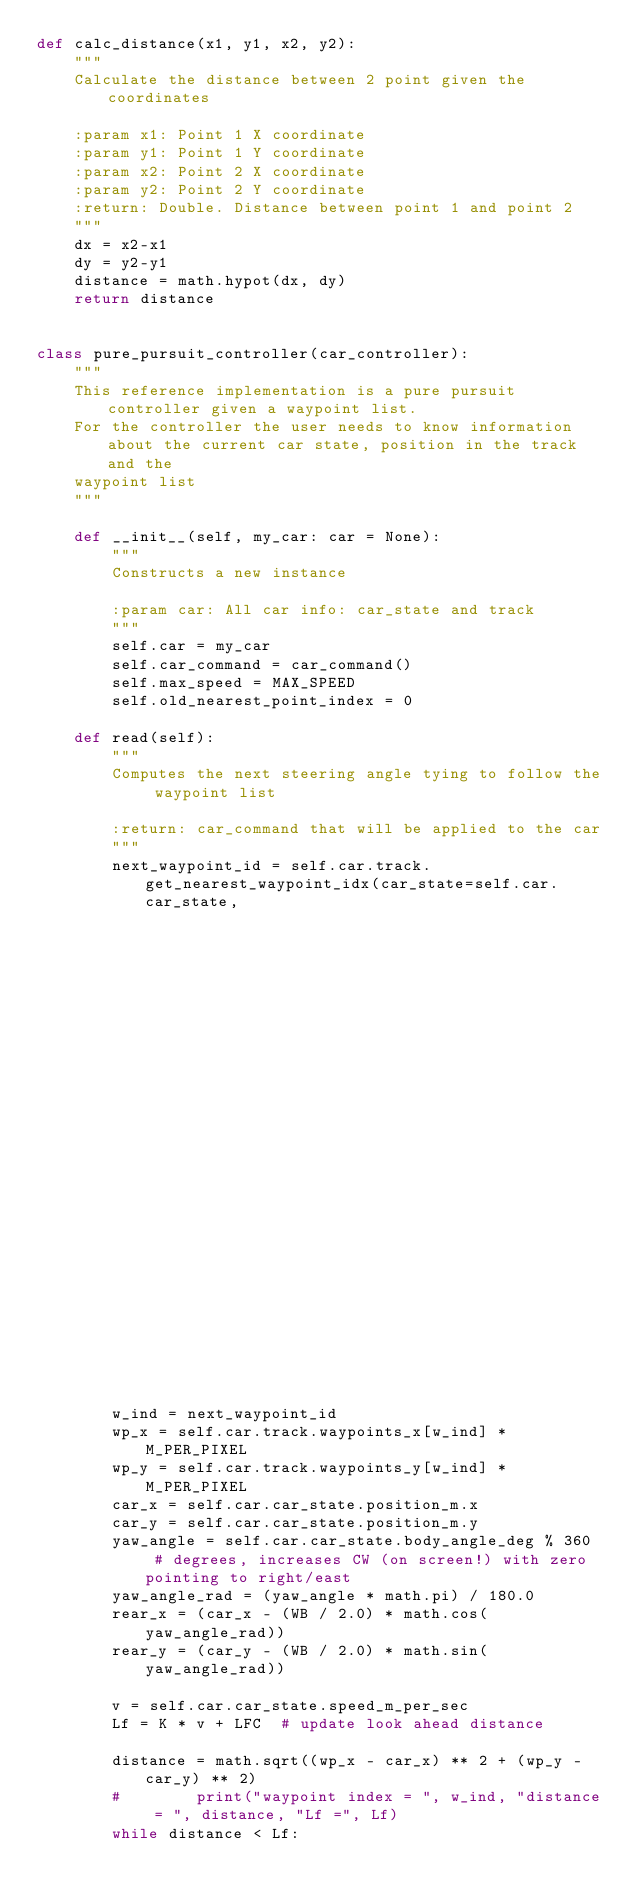Convert code to text. <code><loc_0><loc_0><loc_500><loc_500><_Python_>def calc_distance(x1, y1, x2, y2):
    """
    Calculate the distance between 2 point given the coordinates

    :param x1: Point 1 X coordinate
    :param y1: Point 1 Y coordinate
    :param x2: Point 2 X coordinate
    :param y2: Point 2 Y coordinate
    :return: Double. Distance between point 1 and point 2
    """
    dx = x2-x1
    dy = y2-y1
    distance = math.hypot(dx, dy)
    return distance


class pure_pursuit_controller(car_controller):
    """
    This reference implementation is a pure pursuit controller given a waypoint list.
    For the controller the user needs to know information about the current car state, position in the track and the
    waypoint list
    """

    def __init__(self, my_car: car = None):
        """
        Constructs a new instance

        :param car: All car info: car_state and track
        """
        self.car = my_car
        self.car_command = car_command()
        self.max_speed = MAX_SPEED
        self.old_nearest_point_index = 0

    def read(self):
        """
        Computes the next steering angle tying to follow the waypoint list

        :return: car_command that will be applied to the car
        """
        next_waypoint_id = self.car.track.get_nearest_waypoint_idx(car_state=self.car.car_state,
                                                                   x=self.car.car_state.position_m.x,
                                                                   y=self.car.car_state.position_m.y)

        w_ind = next_waypoint_id
        wp_x = self.car.track.waypoints_x[w_ind] * M_PER_PIXEL
        wp_y = self.car.track.waypoints_y[w_ind] * M_PER_PIXEL
        car_x = self.car.car_state.position_m.x
        car_y = self.car.car_state.position_m.y
        yaw_angle = self.car.car_state.body_angle_deg % 360  # degrees, increases CW (on screen!) with zero pointing to right/east
        yaw_angle_rad = (yaw_angle * math.pi) / 180.0
        rear_x = (car_x - (WB / 2.0) * math.cos(yaw_angle_rad))
        rear_y = (car_y - (WB / 2.0) * math.sin(yaw_angle_rad))

        v = self.car.car_state.speed_m_per_sec
        Lf = K * v + LFC  # update look ahead distance

        distance = math.sqrt((wp_x - car_x) ** 2 + (wp_y - car_y) ** 2)
        #        print("waypoint index = ", w_ind, "distance = ", distance, "Lf =", Lf)
        while distance < Lf:</code> 